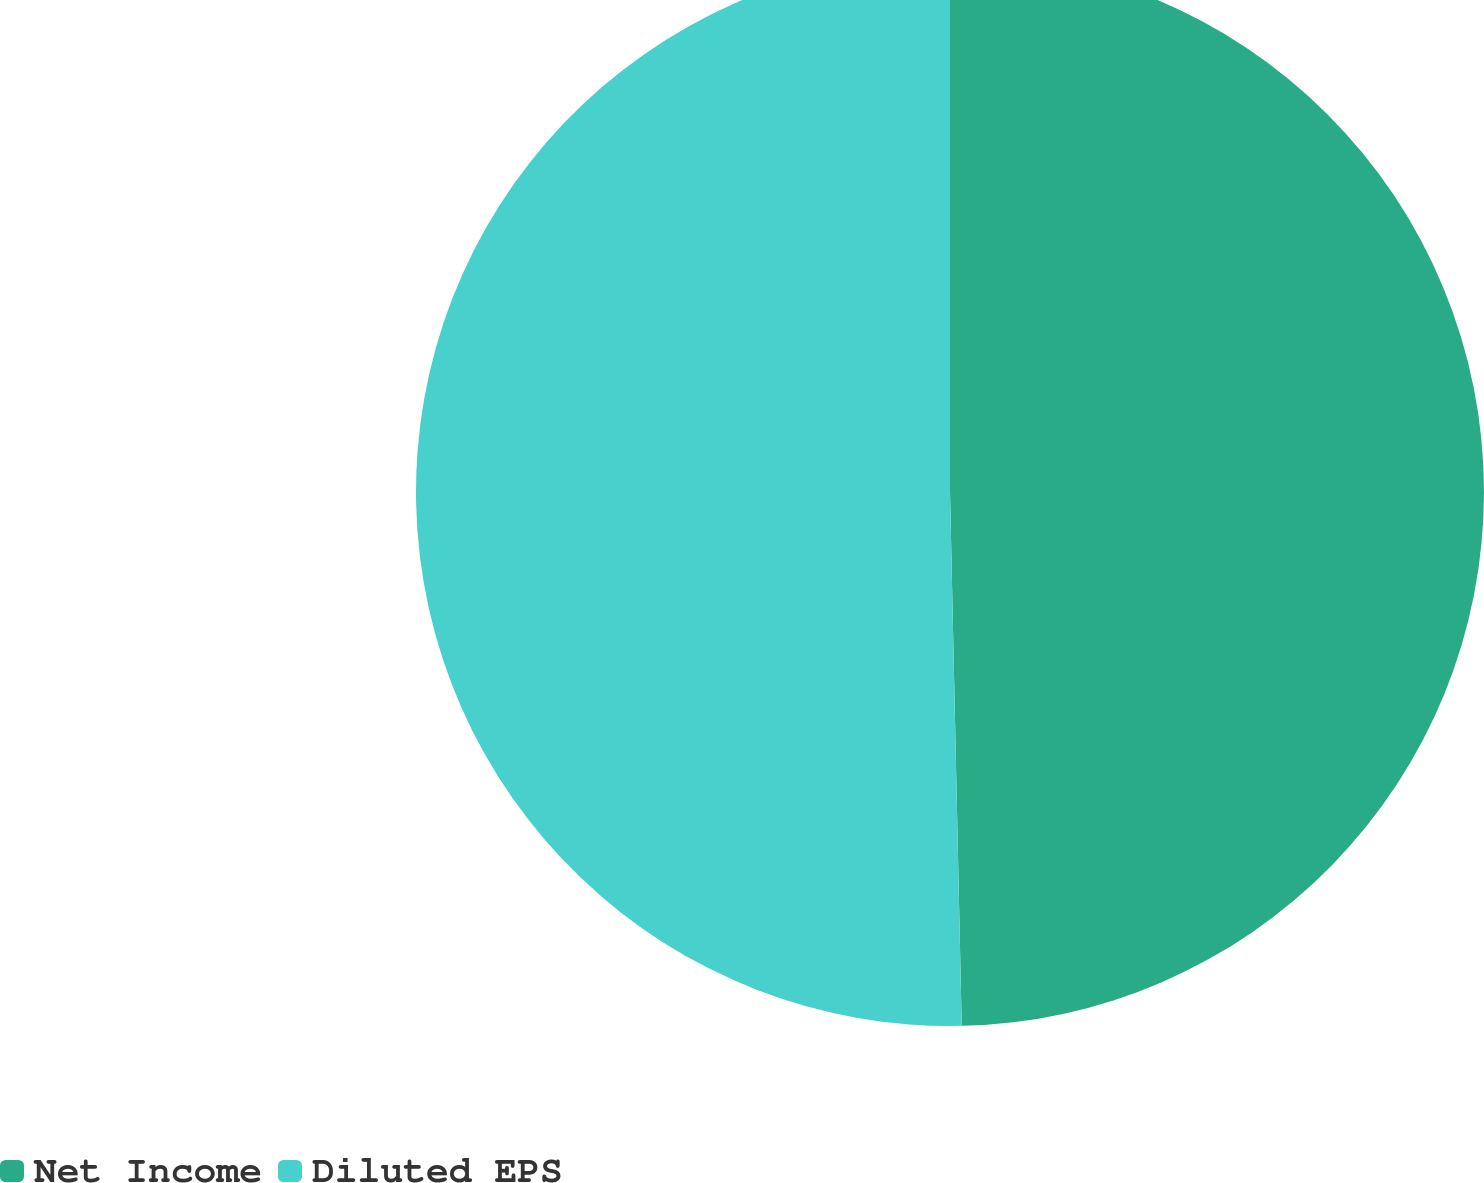<chart> <loc_0><loc_0><loc_500><loc_500><pie_chart><fcel>Net Income<fcel>Diluted EPS<nl><fcel>49.65%<fcel>50.35%<nl></chart> 